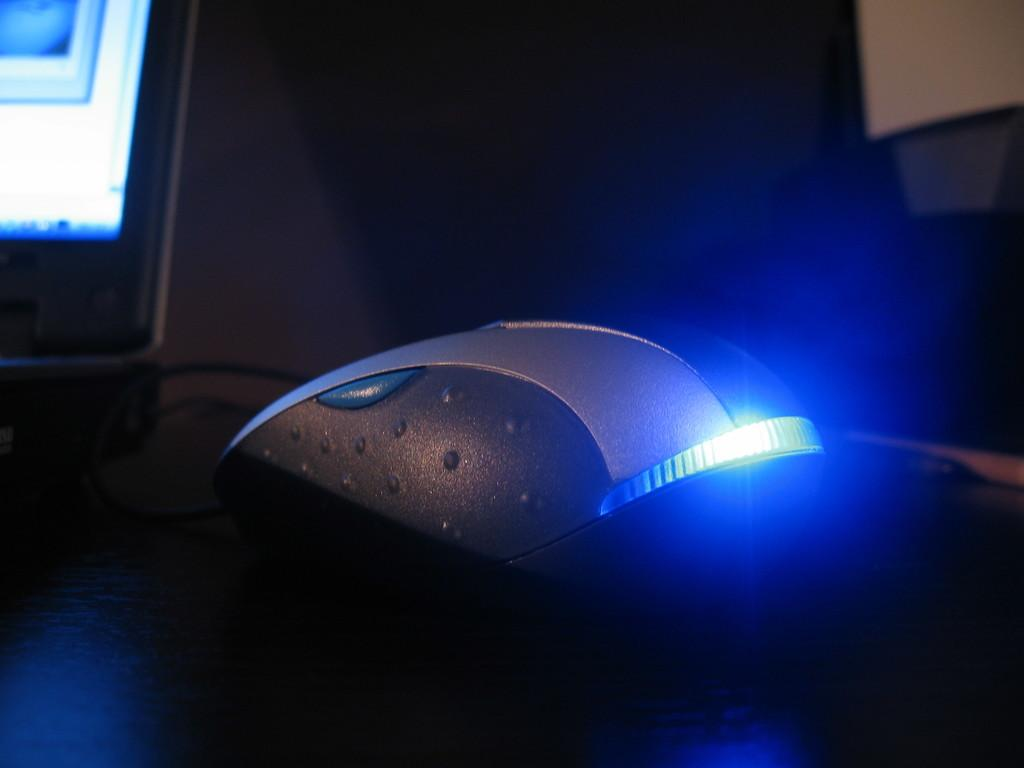What is located on the wooden floor in the image? There is a mouse on the wooden floor in the image. Where is the mouse positioned in the image? The mouse is in the middle of the image. What can be seen on the left side of the image? There is a desktop on the left side of the image. What is visible in the background of the image? There is a wall in the background of the image. What type of ornament is hanging from the carriage in the image? There is no carriage or ornament present in the image; it features a mouse on a wooden floor with a desktop and a wall in the background. 